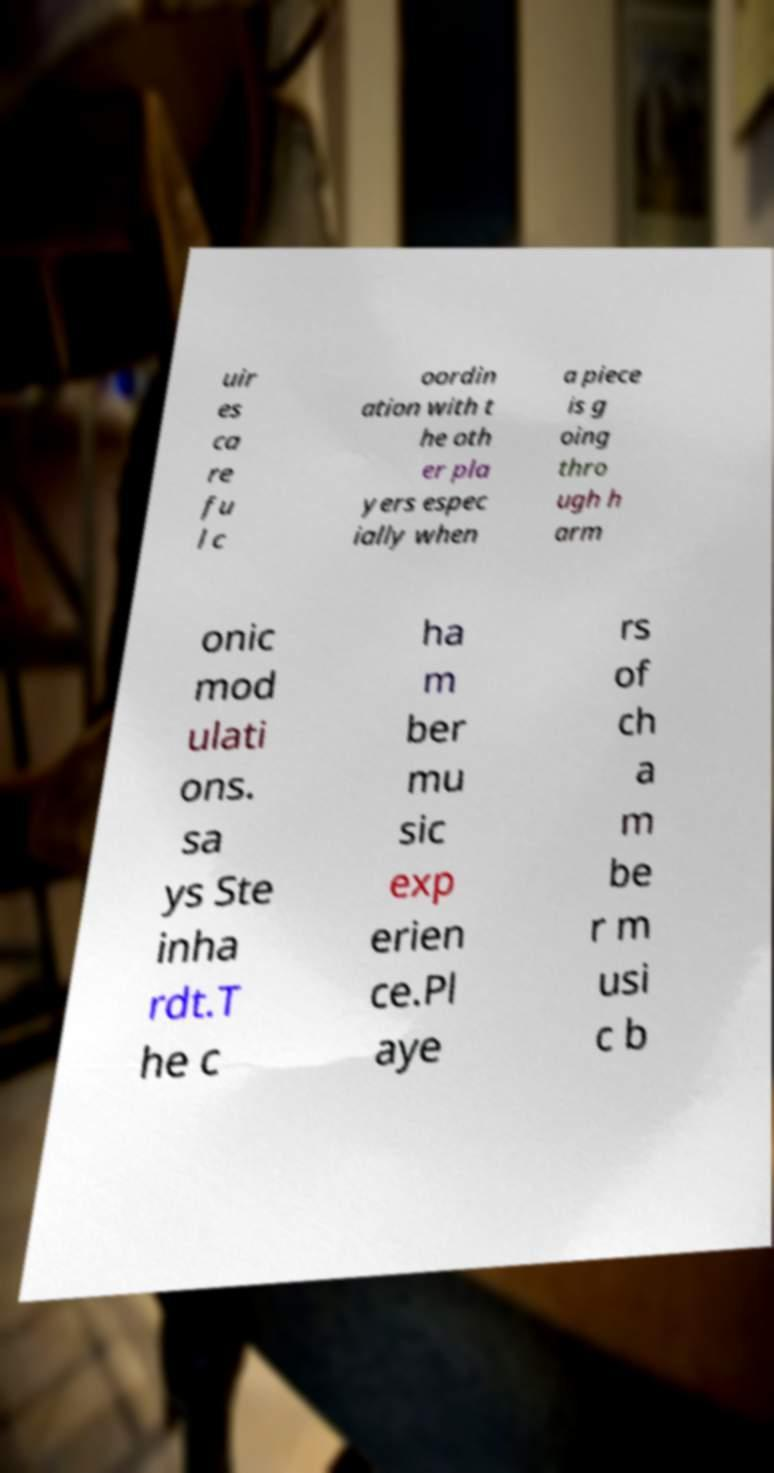There's text embedded in this image that I need extracted. Can you transcribe it verbatim? uir es ca re fu l c oordin ation with t he oth er pla yers espec ially when a piece is g oing thro ugh h arm onic mod ulati ons. sa ys Ste inha rdt.T he c ha m ber mu sic exp erien ce.Pl aye rs of ch a m be r m usi c b 